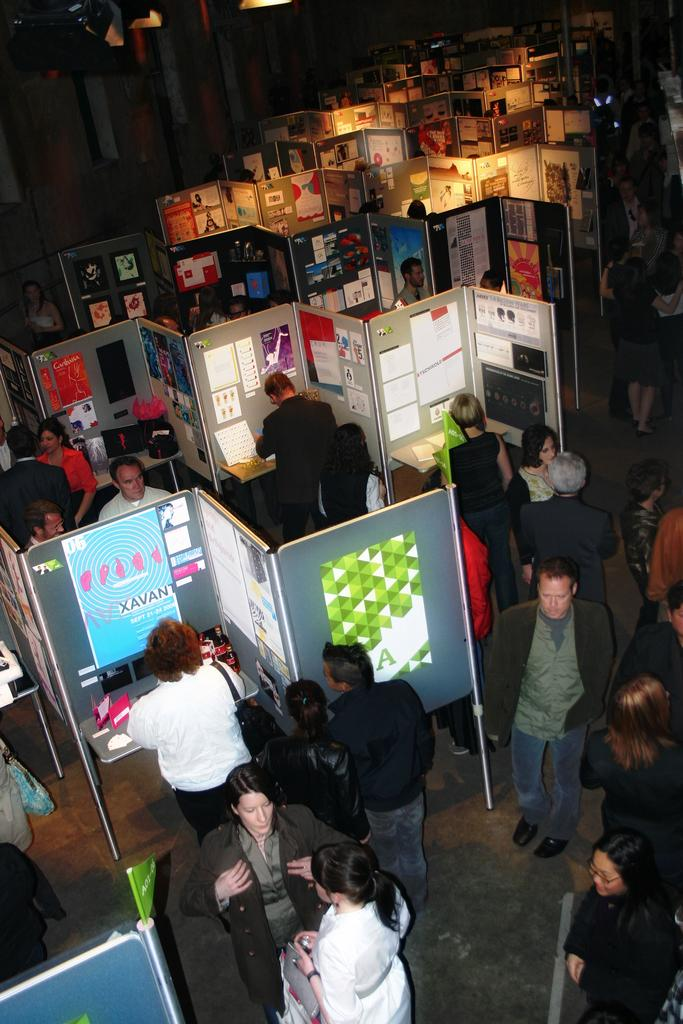How many people are in the image? There is a group of people in the image, but the exact number is not specified. What are the people doing in the image? The people are standing on the ground in the image. What can be seen in front of the group of people? There are posters in front of the group of people. What is the color of the background in the image? The background of the image is dark. What type of pear is being used to spark a conversation among the group of people in the image? There is no pear present in the image, nor is there any indication of a conversation being sparked. 